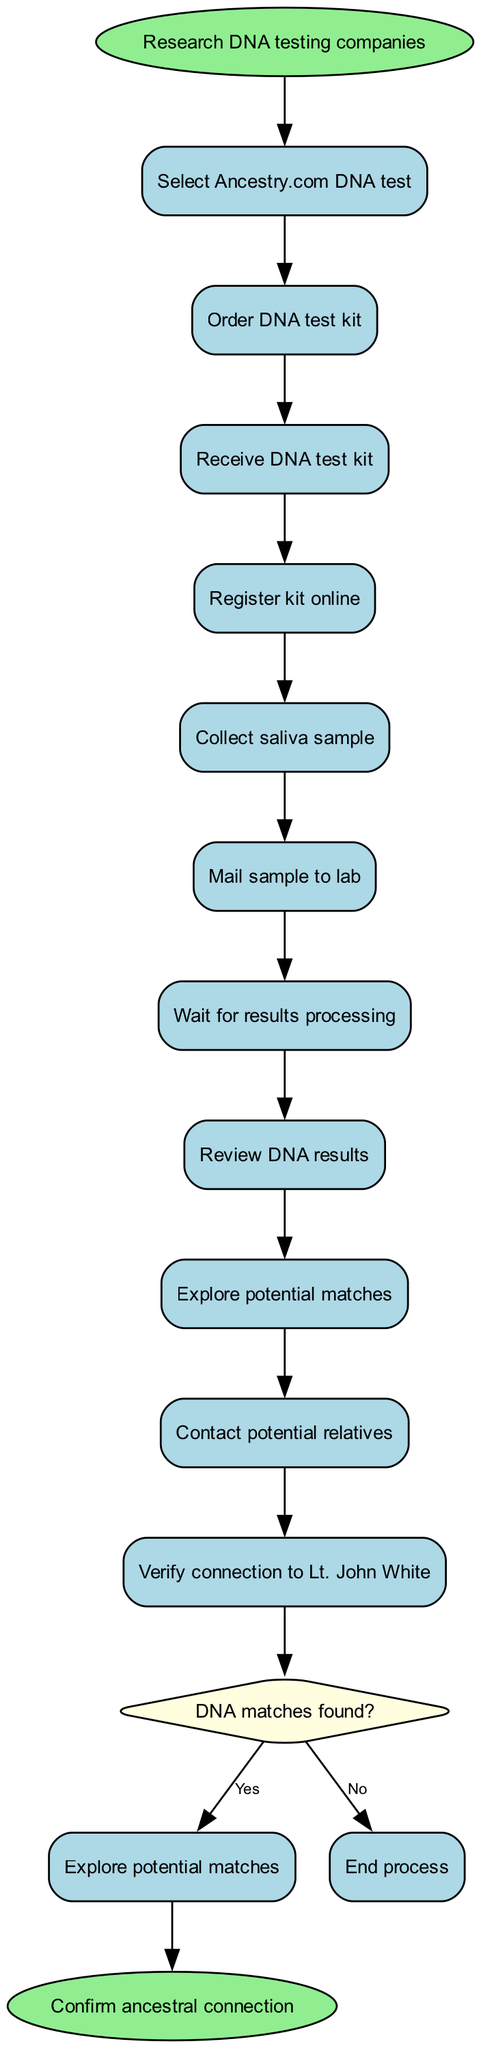what is the initial activity in the diagram? The initial activity is represented at the beginning of the diagram and is directly connected to the start node. According to the provided data, the initial activity listed is "Research DNA testing companies."
Answer: Research DNA testing companies how many activities are in the diagram? To find the number of activities, we can count the items listed in the activities section of the data. There are 11 activities provided.
Answer: 11 what happens after ordering the DNA test kit? After "Order DNA test kit," the flow continues to the next activity in the sequence, which is "Receive DNA test kit."
Answer: Receive DNA test kit what is the decision question in the diagram? The decision node is indicated by the diamond shape and contains the question that guides the flow based on potential outcomes. Here, it states "DNA matches found?"
Answer: DNA matches found? if no DNA matches are found, what is the next step? The next step following a "No" answer to the decision question leads to the end of the process, as indicated in the diagram. Therefore, there is no further activity described.
Answer: End process how many edges connect the activities in the diagram? Edges indicate the flow from one node to another in the diagram. Each activity, except for the last, connects to the next one. With 11 activities, there will be 10 edges connecting them.
Answer: 10 what activity follows after reviewing DNA results? After the activity "Review DNA results," the flow continues to "Explore potential matches," as indicated by the connection in the diagram.
Answer: Explore potential matches how does one verify connection to Lt. John White? The verification of the connection is the last activity mentioned and occurs after contacting potential relatives. As such, it follows the exploration of potential matches and is part of the concluding steps in the process.
Answer: Confirm ancestral connection 